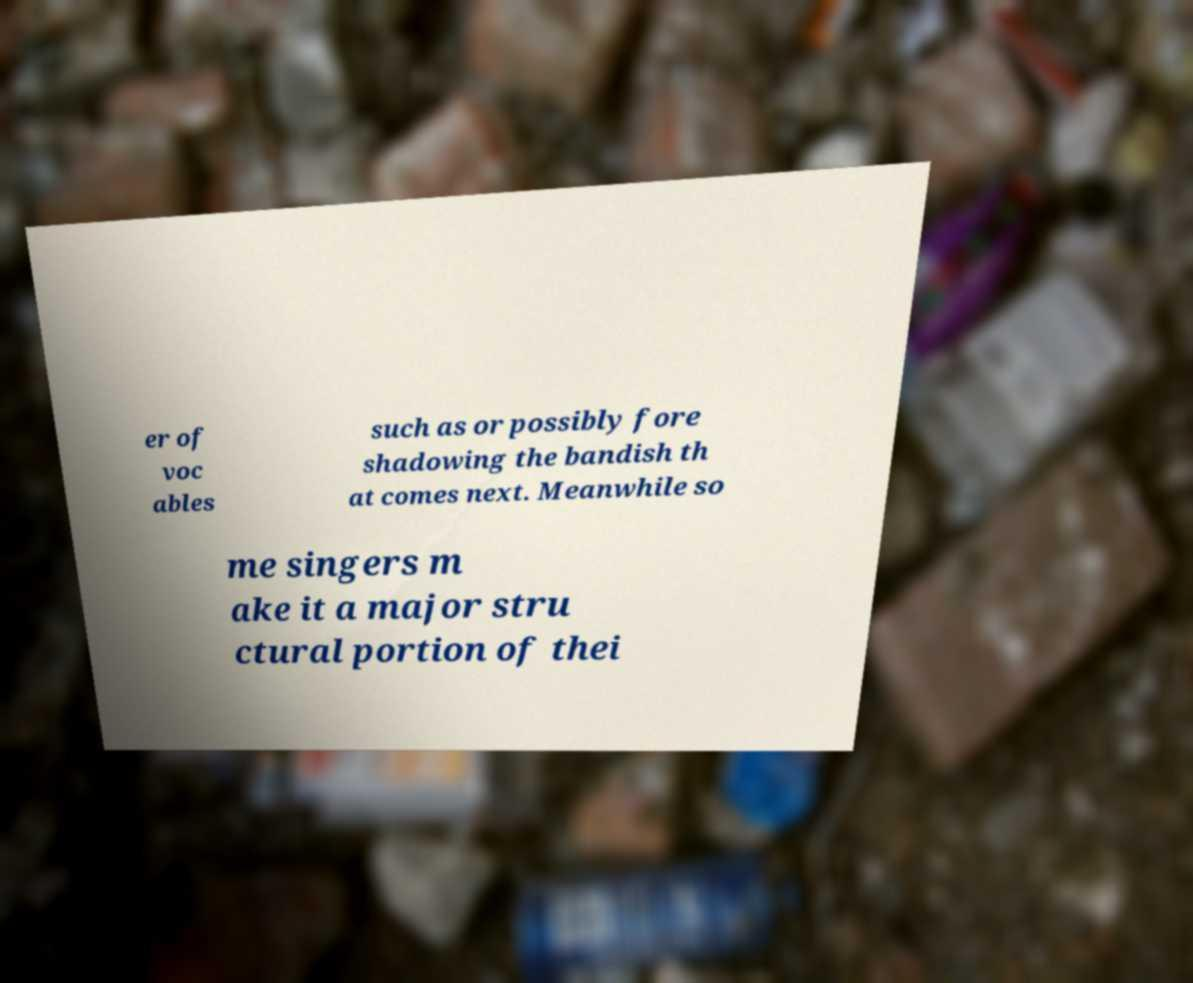Could you extract and type out the text from this image? er of voc ables such as or possibly fore shadowing the bandish th at comes next. Meanwhile so me singers m ake it a major stru ctural portion of thei 